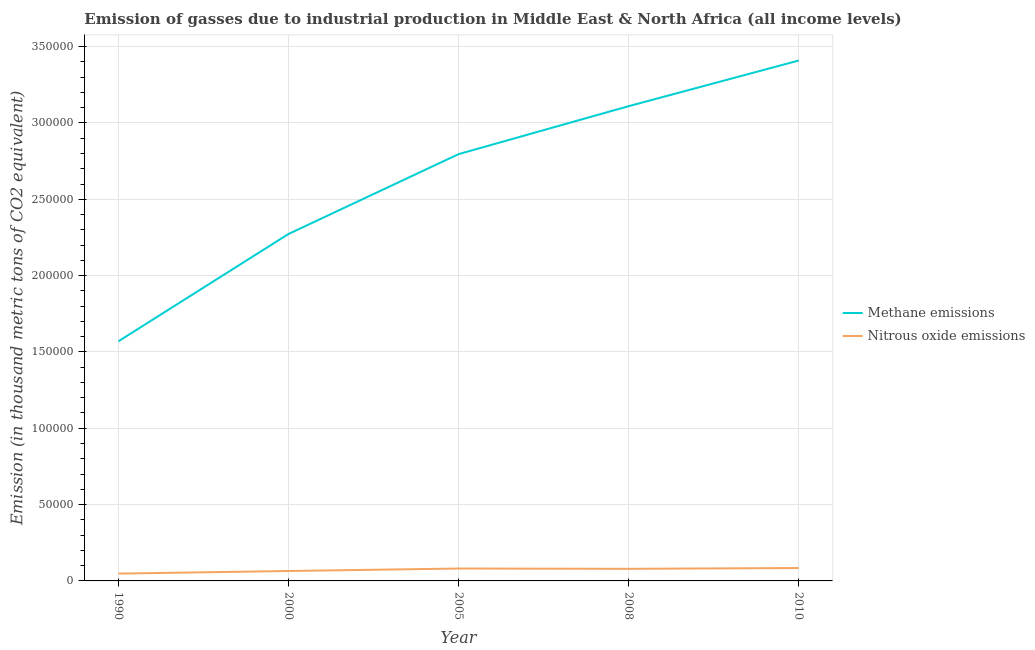How many different coloured lines are there?
Give a very brief answer. 2. What is the amount of methane emissions in 2000?
Your answer should be compact. 2.27e+05. Across all years, what is the maximum amount of methane emissions?
Your response must be concise. 3.41e+05. Across all years, what is the minimum amount of methane emissions?
Ensure brevity in your answer.  1.57e+05. In which year was the amount of nitrous oxide emissions minimum?
Provide a short and direct response. 1990. What is the total amount of methane emissions in the graph?
Provide a short and direct response. 1.32e+06. What is the difference between the amount of methane emissions in 2000 and that in 2008?
Keep it short and to the point. -8.37e+04. What is the difference between the amount of methane emissions in 2008 and the amount of nitrous oxide emissions in 1990?
Your answer should be compact. 3.06e+05. What is the average amount of nitrous oxide emissions per year?
Give a very brief answer. 7156.2. In the year 2005, what is the difference between the amount of nitrous oxide emissions and amount of methane emissions?
Provide a short and direct response. -2.71e+05. What is the ratio of the amount of methane emissions in 2000 to that in 2005?
Offer a terse response. 0.81. Is the amount of nitrous oxide emissions in 2008 less than that in 2010?
Keep it short and to the point. Yes. What is the difference between the highest and the second highest amount of nitrous oxide emissions?
Offer a terse response. 323.9. What is the difference between the highest and the lowest amount of methane emissions?
Offer a terse response. 1.84e+05. In how many years, is the amount of nitrous oxide emissions greater than the average amount of nitrous oxide emissions taken over all years?
Offer a terse response. 3. How many lines are there?
Provide a succinct answer. 2. How many years are there in the graph?
Ensure brevity in your answer.  5. What is the difference between two consecutive major ticks on the Y-axis?
Provide a succinct answer. 5.00e+04. Are the values on the major ticks of Y-axis written in scientific E-notation?
Offer a terse response. No. What is the title of the graph?
Ensure brevity in your answer.  Emission of gasses due to industrial production in Middle East & North Africa (all income levels). What is the label or title of the Y-axis?
Ensure brevity in your answer.  Emission (in thousand metric tons of CO2 equivalent). What is the Emission (in thousand metric tons of CO2 equivalent) of Methane emissions in 1990?
Make the answer very short. 1.57e+05. What is the Emission (in thousand metric tons of CO2 equivalent) of Nitrous oxide emissions in 1990?
Keep it short and to the point. 4795.2. What is the Emission (in thousand metric tons of CO2 equivalent) of Methane emissions in 2000?
Provide a succinct answer. 2.27e+05. What is the Emission (in thousand metric tons of CO2 equivalent) in Nitrous oxide emissions in 2000?
Your response must be concise. 6497. What is the Emission (in thousand metric tons of CO2 equivalent) of Methane emissions in 2005?
Provide a short and direct response. 2.80e+05. What is the Emission (in thousand metric tons of CO2 equivalent) of Nitrous oxide emissions in 2005?
Your answer should be very brief. 8118.6. What is the Emission (in thousand metric tons of CO2 equivalent) of Methane emissions in 2008?
Provide a succinct answer. 3.11e+05. What is the Emission (in thousand metric tons of CO2 equivalent) in Nitrous oxide emissions in 2008?
Make the answer very short. 7927.7. What is the Emission (in thousand metric tons of CO2 equivalent) in Methane emissions in 2010?
Offer a terse response. 3.41e+05. What is the Emission (in thousand metric tons of CO2 equivalent) of Nitrous oxide emissions in 2010?
Give a very brief answer. 8442.5. Across all years, what is the maximum Emission (in thousand metric tons of CO2 equivalent) in Methane emissions?
Keep it short and to the point. 3.41e+05. Across all years, what is the maximum Emission (in thousand metric tons of CO2 equivalent) of Nitrous oxide emissions?
Make the answer very short. 8442.5. Across all years, what is the minimum Emission (in thousand metric tons of CO2 equivalent) of Methane emissions?
Your response must be concise. 1.57e+05. Across all years, what is the minimum Emission (in thousand metric tons of CO2 equivalent) in Nitrous oxide emissions?
Your answer should be compact. 4795.2. What is the total Emission (in thousand metric tons of CO2 equivalent) of Methane emissions in the graph?
Your response must be concise. 1.32e+06. What is the total Emission (in thousand metric tons of CO2 equivalent) of Nitrous oxide emissions in the graph?
Keep it short and to the point. 3.58e+04. What is the difference between the Emission (in thousand metric tons of CO2 equivalent) in Methane emissions in 1990 and that in 2000?
Keep it short and to the point. -7.03e+04. What is the difference between the Emission (in thousand metric tons of CO2 equivalent) in Nitrous oxide emissions in 1990 and that in 2000?
Offer a terse response. -1701.8. What is the difference between the Emission (in thousand metric tons of CO2 equivalent) of Methane emissions in 1990 and that in 2005?
Make the answer very short. -1.23e+05. What is the difference between the Emission (in thousand metric tons of CO2 equivalent) of Nitrous oxide emissions in 1990 and that in 2005?
Your answer should be compact. -3323.4. What is the difference between the Emission (in thousand metric tons of CO2 equivalent) of Methane emissions in 1990 and that in 2008?
Provide a succinct answer. -1.54e+05. What is the difference between the Emission (in thousand metric tons of CO2 equivalent) in Nitrous oxide emissions in 1990 and that in 2008?
Offer a terse response. -3132.5. What is the difference between the Emission (in thousand metric tons of CO2 equivalent) of Methane emissions in 1990 and that in 2010?
Make the answer very short. -1.84e+05. What is the difference between the Emission (in thousand metric tons of CO2 equivalent) in Nitrous oxide emissions in 1990 and that in 2010?
Give a very brief answer. -3647.3. What is the difference between the Emission (in thousand metric tons of CO2 equivalent) of Methane emissions in 2000 and that in 2005?
Offer a terse response. -5.23e+04. What is the difference between the Emission (in thousand metric tons of CO2 equivalent) of Nitrous oxide emissions in 2000 and that in 2005?
Your response must be concise. -1621.6. What is the difference between the Emission (in thousand metric tons of CO2 equivalent) of Methane emissions in 2000 and that in 2008?
Offer a very short reply. -8.37e+04. What is the difference between the Emission (in thousand metric tons of CO2 equivalent) of Nitrous oxide emissions in 2000 and that in 2008?
Offer a terse response. -1430.7. What is the difference between the Emission (in thousand metric tons of CO2 equivalent) of Methane emissions in 2000 and that in 2010?
Your answer should be very brief. -1.14e+05. What is the difference between the Emission (in thousand metric tons of CO2 equivalent) of Nitrous oxide emissions in 2000 and that in 2010?
Your response must be concise. -1945.5. What is the difference between the Emission (in thousand metric tons of CO2 equivalent) of Methane emissions in 2005 and that in 2008?
Provide a short and direct response. -3.14e+04. What is the difference between the Emission (in thousand metric tons of CO2 equivalent) in Nitrous oxide emissions in 2005 and that in 2008?
Offer a very short reply. 190.9. What is the difference between the Emission (in thousand metric tons of CO2 equivalent) in Methane emissions in 2005 and that in 2010?
Your answer should be compact. -6.13e+04. What is the difference between the Emission (in thousand metric tons of CO2 equivalent) of Nitrous oxide emissions in 2005 and that in 2010?
Offer a terse response. -323.9. What is the difference between the Emission (in thousand metric tons of CO2 equivalent) of Methane emissions in 2008 and that in 2010?
Ensure brevity in your answer.  -2.99e+04. What is the difference between the Emission (in thousand metric tons of CO2 equivalent) of Nitrous oxide emissions in 2008 and that in 2010?
Your response must be concise. -514.8. What is the difference between the Emission (in thousand metric tons of CO2 equivalent) of Methane emissions in 1990 and the Emission (in thousand metric tons of CO2 equivalent) of Nitrous oxide emissions in 2000?
Give a very brief answer. 1.50e+05. What is the difference between the Emission (in thousand metric tons of CO2 equivalent) in Methane emissions in 1990 and the Emission (in thousand metric tons of CO2 equivalent) in Nitrous oxide emissions in 2005?
Give a very brief answer. 1.49e+05. What is the difference between the Emission (in thousand metric tons of CO2 equivalent) in Methane emissions in 1990 and the Emission (in thousand metric tons of CO2 equivalent) in Nitrous oxide emissions in 2008?
Your answer should be compact. 1.49e+05. What is the difference between the Emission (in thousand metric tons of CO2 equivalent) in Methane emissions in 1990 and the Emission (in thousand metric tons of CO2 equivalent) in Nitrous oxide emissions in 2010?
Offer a very short reply. 1.49e+05. What is the difference between the Emission (in thousand metric tons of CO2 equivalent) of Methane emissions in 2000 and the Emission (in thousand metric tons of CO2 equivalent) of Nitrous oxide emissions in 2005?
Give a very brief answer. 2.19e+05. What is the difference between the Emission (in thousand metric tons of CO2 equivalent) of Methane emissions in 2000 and the Emission (in thousand metric tons of CO2 equivalent) of Nitrous oxide emissions in 2008?
Your answer should be compact. 2.19e+05. What is the difference between the Emission (in thousand metric tons of CO2 equivalent) of Methane emissions in 2000 and the Emission (in thousand metric tons of CO2 equivalent) of Nitrous oxide emissions in 2010?
Make the answer very short. 2.19e+05. What is the difference between the Emission (in thousand metric tons of CO2 equivalent) of Methane emissions in 2005 and the Emission (in thousand metric tons of CO2 equivalent) of Nitrous oxide emissions in 2008?
Offer a terse response. 2.72e+05. What is the difference between the Emission (in thousand metric tons of CO2 equivalent) in Methane emissions in 2005 and the Emission (in thousand metric tons of CO2 equivalent) in Nitrous oxide emissions in 2010?
Keep it short and to the point. 2.71e+05. What is the difference between the Emission (in thousand metric tons of CO2 equivalent) of Methane emissions in 2008 and the Emission (in thousand metric tons of CO2 equivalent) of Nitrous oxide emissions in 2010?
Provide a succinct answer. 3.03e+05. What is the average Emission (in thousand metric tons of CO2 equivalent) of Methane emissions per year?
Your response must be concise. 2.63e+05. What is the average Emission (in thousand metric tons of CO2 equivalent) in Nitrous oxide emissions per year?
Provide a succinct answer. 7156.2. In the year 1990, what is the difference between the Emission (in thousand metric tons of CO2 equivalent) of Methane emissions and Emission (in thousand metric tons of CO2 equivalent) of Nitrous oxide emissions?
Give a very brief answer. 1.52e+05. In the year 2000, what is the difference between the Emission (in thousand metric tons of CO2 equivalent) in Methane emissions and Emission (in thousand metric tons of CO2 equivalent) in Nitrous oxide emissions?
Provide a short and direct response. 2.21e+05. In the year 2005, what is the difference between the Emission (in thousand metric tons of CO2 equivalent) in Methane emissions and Emission (in thousand metric tons of CO2 equivalent) in Nitrous oxide emissions?
Give a very brief answer. 2.71e+05. In the year 2008, what is the difference between the Emission (in thousand metric tons of CO2 equivalent) of Methane emissions and Emission (in thousand metric tons of CO2 equivalent) of Nitrous oxide emissions?
Offer a very short reply. 3.03e+05. In the year 2010, what is the difference between the Emission (in thousand metric tons of CO2 equivalent) of Methane emissions and Emission (in thousand metric tons of CO2 equivalent) of Nitrous oxide emissions?
Your answer should be very brief. 3.32e+05. What is the ratio of the Emission (in thousand metric tons of CO2 equivalent) of Methane emissions in 1990 to that in 2000?
Your answer should be very brief. 0.69. What is the ratio of the Emission (in thousand metric tons of CO2 equivalent) of Nitrous oxide emissions in 1990 to that in 2000?
Ensure brevity in your answer.  0.74. What is the ratio of the Emission (in thousand metric tons of CO2 equivalent) in Methane emissions in 1990 to that in 2005?
Ensure brevity in your answer.  0.56. What is the ratio of the Emission (in thousand metric tons of CO2 equivalent) of Nitrous oxide emissions in 1990 to that in 2005?
Give a very brief answer. 0.59. What is the ratio of the Emission (in thousand metric tons of CO2 equivalent) in Methane emissions in 1990 to that in 2008?
Make the answer very short. 0.5. What is the ratio of the Emission (in thousand metric tons of CO2 equivalent) of Nitrous oxide emissions in 1990 to that in 2008?
Your answer should be compact. 0.6. What is the ratio of the Emission (in thousand metric tons of CO2 equivalent) of Methane emissions in 1990 to that in 2010?
Offer a very short reply. 0.46. What is the ratio of the Emission (in thousand metric tons of CO2 equivalent) in Nitrous oxide emissions in 1990 to that in 2010?
Make the answer very short. 0.57. What is the ratio of the Emission (in thousand metric tons of CO2 equivalent) in Methane emissions in 2000 to that in 2005?
Provide a succinct answer. 0.81. What is the ratio of the Emission (in thousand metric tons of CO2 equivalent) in Nitrous oxide emissions in 2000 to that in 2005?
Provide a short and direct response. 0.8. What is the ratio of the Emission (in thousand metric tons of CO2 equivalent) in Methane emissions in 2000 to that in 2008?
Offer a very short reply. 0.73. What is the ratio of the Emission (in thousand metric tons of CO2 equivalent) of Nitrous oxide emissions in 2000 to that in 2008?
Give a very brief answer. 0.82. What is the ratio of the Emission (in thousand metric tons of CO2 equivalent) in Methane emissions in 2000 to that in 2010?
Give a very brief answer. 0.67. What is the ratio of the Emission (in thousand metric tons of CO2 equivalent) in Nitrous oxide emissions in 2000 to that in 2010?
Provide a succinct answer. 0.77. What is the ratio of the Emission (in thousand metric tons of CO2 equivalent) in Methane emissions in 2005 to that in 2008?
Offer a very short reply. 0.9. What is the ratio of the Emission (in thousand metric tons of CO2 equivalent) in Nitrous oxide emissions in 2005 to that in 2008?
Provide a succinct answer. 1.02. What is the ratio of the Emission (in thousand metric tons of CO2 equivalent) in Methane emissions in 2005 to that in 2010?
Provide a succinct answer. 0.82. What is the ratio of the Emission (in thousand metric tons of CO2 equivalent) in Nitrous oxide emissions in 2005 to that in 2010?
Ensure brevity in your answer.  0.96. What is the ratio of the Emission (in thousand metric tons of CO2 equivalent) in Methane emissions in 2008 to that in 2010?
Your response must be concise. 0.91. What is the ratio of the Emission (in thousand metric tons of CO2 equivalent) in Nitrous oxide emissions in 2008 to that in 2010?
Your answer should be compact. 0.94. What is the difference between the highest and the second highest Emission (in thousand metric tons of CO2 equivalent) in Methane emissions?
Make the answer very short. 2.99e+04. What is the difference between the highest and the second highest Emission (in thousand metric tons of CO2 equivalent) of Nitrous oxide emissions?
Your answer should be very brief. 323.9. What is the difference between the highest and the lowest Emission (in thousand metric tons of CO2 equivalent) of Methane emissions?
Your answer should be compact. 1.84e+05. What is the difference between the highest and the lowest Emission (in thousand metric tons of CO2 equivalent) of Nitrous oxide emissions?
Offer a terse response. 3647.3. 